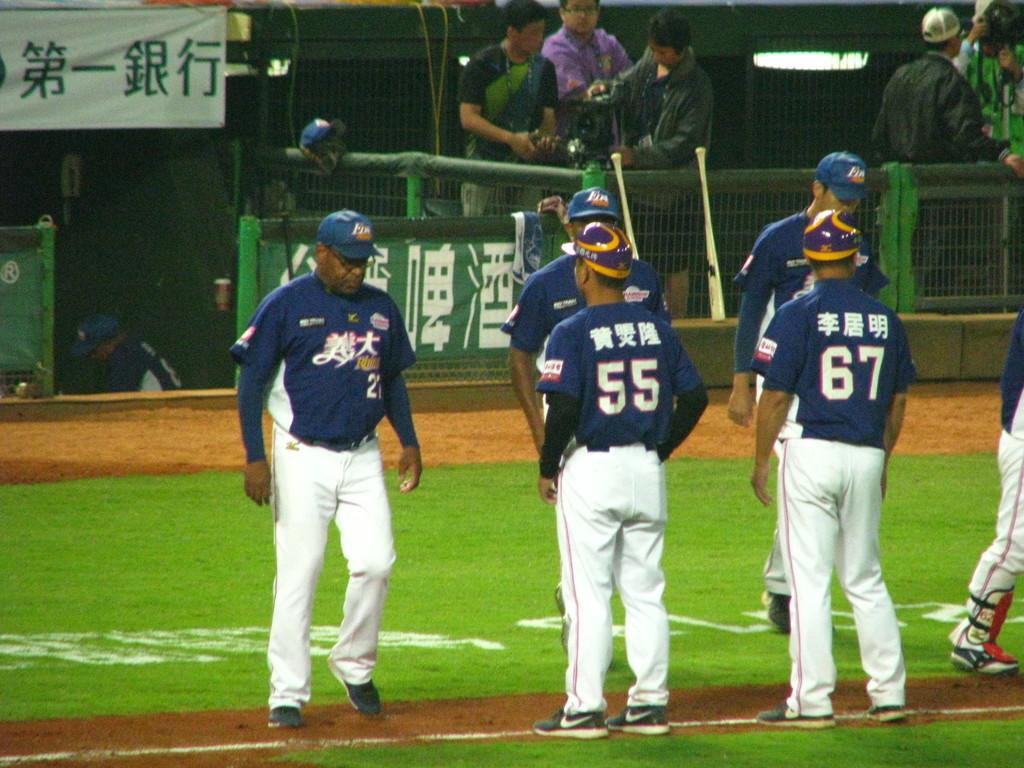What are these players' numbers?
Give a very brief answer. 55 67. 